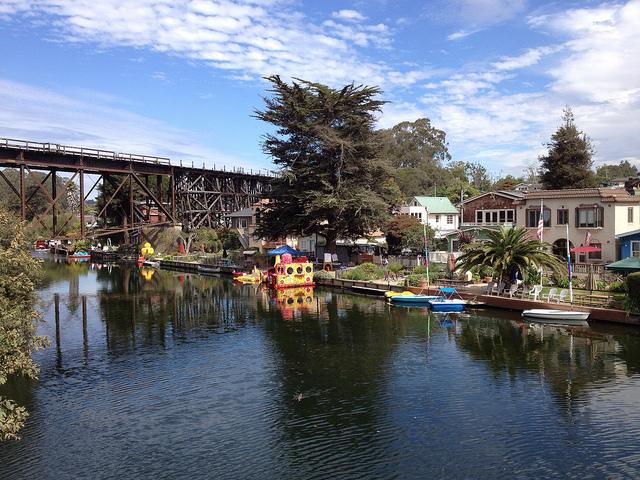Is there an animal on the water?
Keep it brief. Yes. What is this a picture of?
Answer briefly. Lake. How many boats in this photo?
Write a very short answer. 3. 